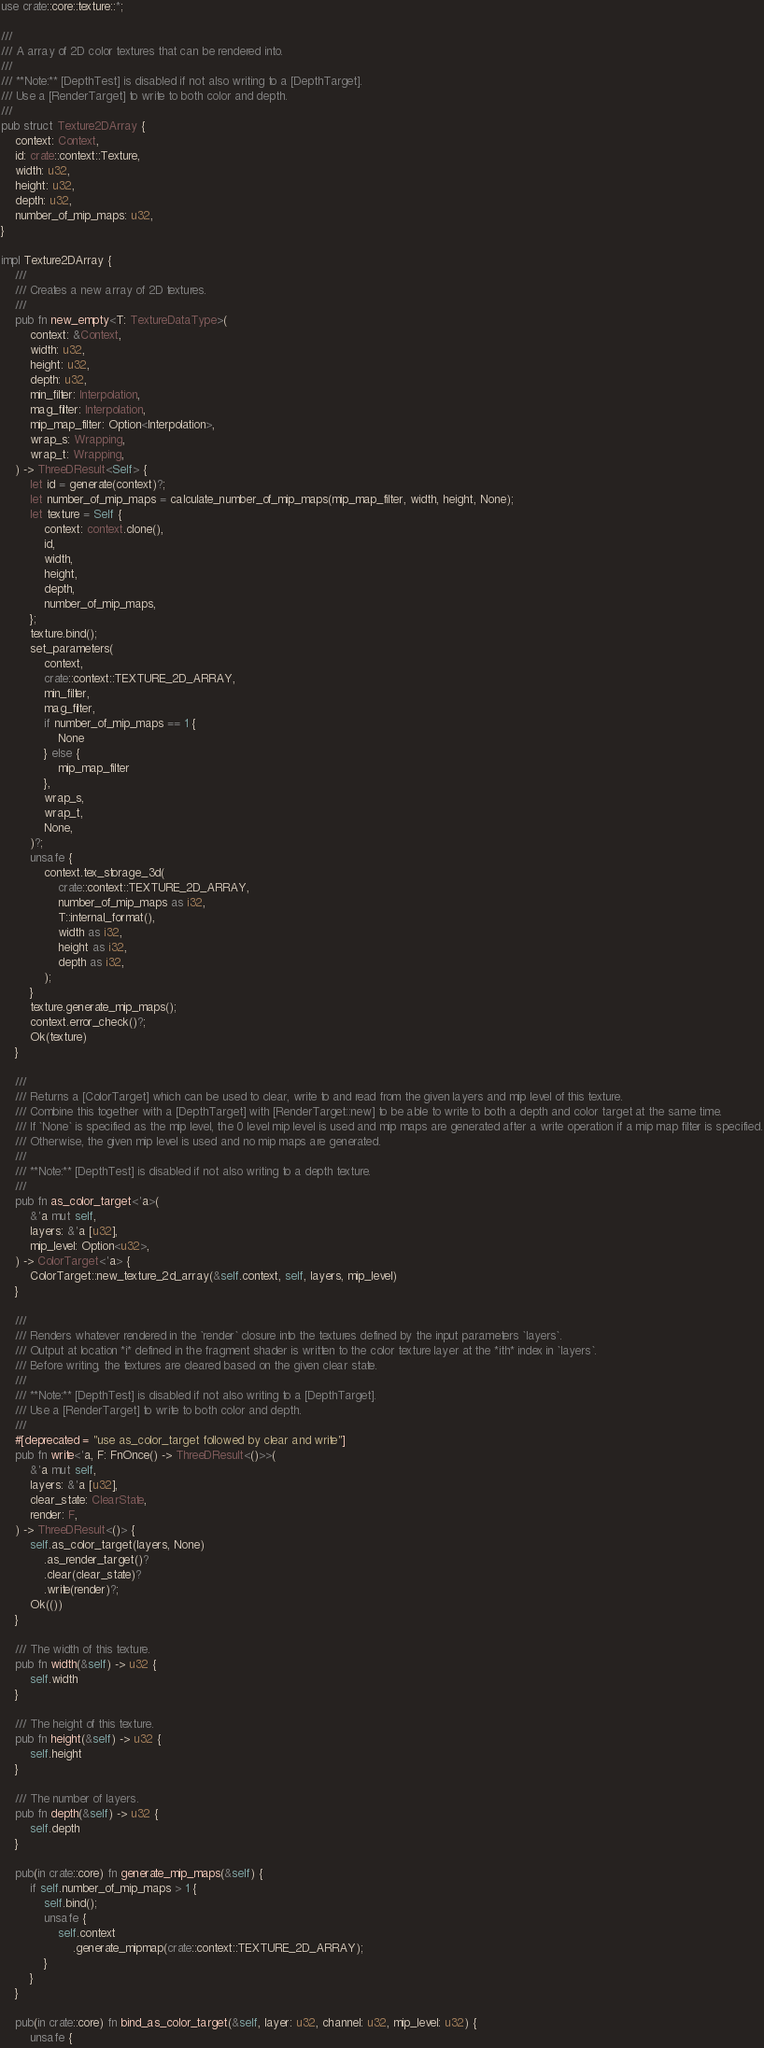<code> <loc_0><loc_0><loc_500><loc_500><_Rust_>use crate::core::texture::*;

///
/// A array of 2D color textures that can be rendered into.
///
/// **Note:** [DepthTest] is disabled if not also writing to a [DepthTarget].
/// Use a [RenderTarget] to write to both color and depth.
///
pub struct Texture2DArray {
    context: Context,
    id: crate::context::Texture,
    width: u32,
    height: u32,
    depth: u32,
    number_of_mip_maps: u32,
}

impl Texture2DArray {
    ///
    /// Creates a new array of 2D textures.
    ///
    pub fn new_empty<T: TextureDataType>(
        context: &Context,
        width: u32,
        height: u32,
        depth: u32,
        min_filter: Interpolation,
        mag_filter: Interpolation,
        mip_map_filter: Option<Interpolation>,
        wrap_s: Wrapping,
        wrap_t: Wrapping,
    ) -> ThreeDResult<Self> {
        let id = generate(context)?;
        let number_of_mip_maps = calculate_number_of_mip_maps(mip_map_filter, width, height, None);
        let texture = Self {
            context: context.clone(),
            id,
            width,
            height,
            depth,
            number_of_mip_maps,
        };
        texture.bind();
        set_parameters(
            context,
            crate::context::TEXTURE_2D_ARRAY,
            min_filter,
            mag_filter,
            if number_of_mip_maps == 1 {
                None
            } else {
                mip_map_filter
            },
            wrap_s,
            wrap_t,
            None,
        )?;
        unsafe {
            context.tex_storage_3d(
                crate::context::TEXTURE_2D_ARRAY,
                number_of_mip_maps as i32,
                T::internal_format(),
                width as i32,
                height as i32,
                depth as i32,
            );
        }
        texture.generate_mip_maps();
        context.error_check()?;
        Ok(texture)
    }

    ///
    /// Returns a [ColorTarget] which can be used to clear, write to and read from the given layers and mip level of this texture.
    /// Combine this together with a [DepthTarget] with [RenderTarget::new] to be able to write to both a depth and color target at the same time.
    /// If `None` is specified as the mip level, the 0 level mip level is used and mip maps are generated after a write operation if a mip map filter is specified.
    /// Otherwise, the given mip level is used and no mip maps are generated.
    ///
    /// **Note:** [DepthTest] is disabled if not also writing to a depth texture.
    ///
    pub fn as_color_target<'a>(
        &'a mut self,
        layers: &'a [u32],
        mip_level: Option<u32>,
    ) -> ColorTarget<'a> {
        ColorTarget::new_texture_2d_array(&self.context, self, layers, mip_level)
    }

    ///
    /// Renders whatever rendered in the `render` closure into the textures defined by the input parameters `layers`.
    /// Output at location *i* defined in the fragment shader is written to the color texture layer at the *ith* index in `layers`.
    /// Before writing, the textures are cleared based on the given clear state.
    ///
    /// **Note:** [DepthTest] is disabled if not also writing to a [DepthTarget].
    /// Use a [RenderTarget] to write to both color and depth.
    ///
    #[deprecated = "use as_color_target followed by clear and write"]
    pub fn write<'a, F: FnOnce() -> ThreeDResult<()>>(
        &'a mut self,
        layers: &'a [u32],
        clear_state: ClearState,
        render: F,
    ) -> ThreeDResult<()> {
        self.as_color_target(layers, None)
            .as_render_target()?
            .clear(clear_state)?
            .write(render)?;
        Ok(())
    }

    /// The width of this texture.
    pub fn width(&self) -> u32 {
        self.width
    }

    /// The height of this texture.
    pub fn height(&self) -> u32 {
        self.height
    }

    /// The number of layers.
    pub fn depth(&self) -> u32 {
        self.depth
    }

    pub(in crate::core) fn generate_mip_maps(&self) {
        if self.number_of_mip_maps > 1 {
            self.bind();
            unsafe {
                self.context
                    .generate_mipmap(crate::context::TEXTURE_2D_ARRAY);
            }
        }
    }

    pub(in crate::core) fn bind_as_color_target(&self, layer: u32, channel: u32, mip_level: u32) {
        unsafe {</code> 